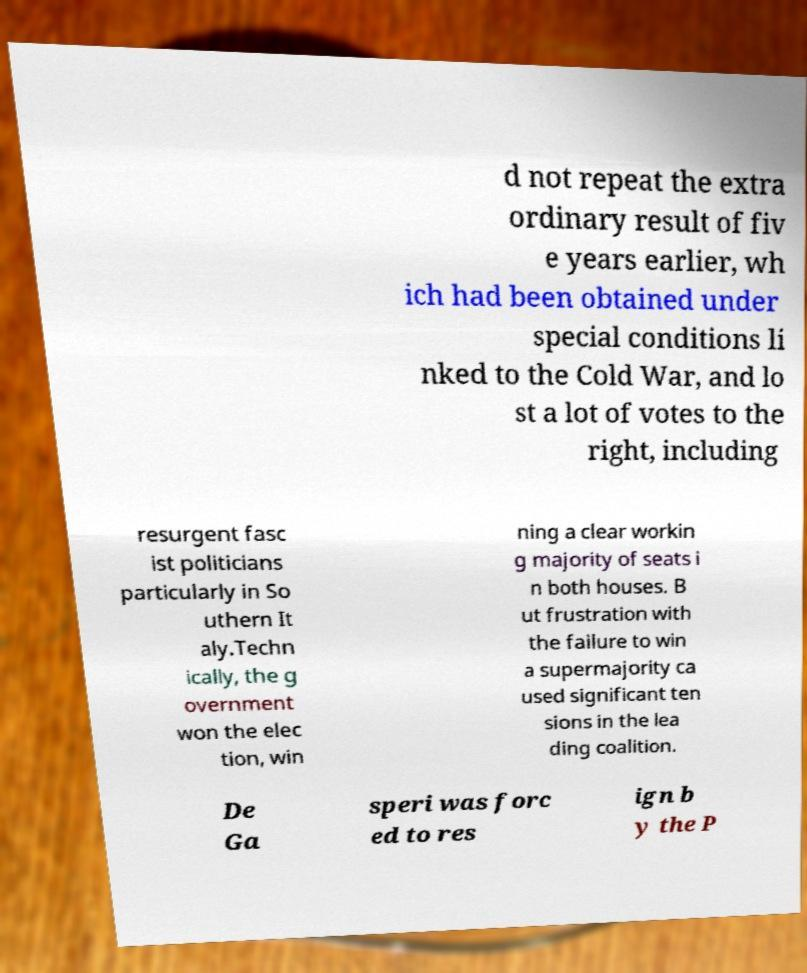Please identify and transcribe the text found in this image. d not repeat the extra ordinary result of fiv e years earlier, wh ich had been obtained under special conditions li nked to the Cold War, and lo st a lot of votes to the right, including resurgent fasc ist politicians particularly in So uthern It aly.Techn ically, the g overnment won the elec tion, win ning a clear workin g majority of seats i n both houses. B ut frustration with the failure to win a supermajority ca used significant ten sions in the lea ding coalition. De Ga speri was forc ed to res ign b y the P 